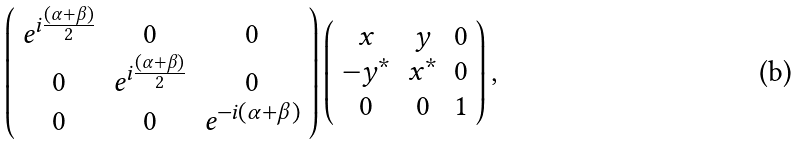<formula> <loc_0><loc_0><loc_500><loc_500>\left ( \begin{array} { c c c } e ^ { i \frac { ( \alpha + \beta ) } { 2 } } & 0 & 0 \\ 0 & e ^ { i \frac { ( \alpha + \beta ) } { 2 } } & 0 \\ 0 & 0 & e ^ { - i ( \alpha + \beta ) } \end{array} \right ) \left ( \begin{array} { c c c } x & y & 0 \\ - y ^ { * } & x ^ { * } & 0 \\ 0 & 0 & 1 \end{array} \right ) ,</formula> 